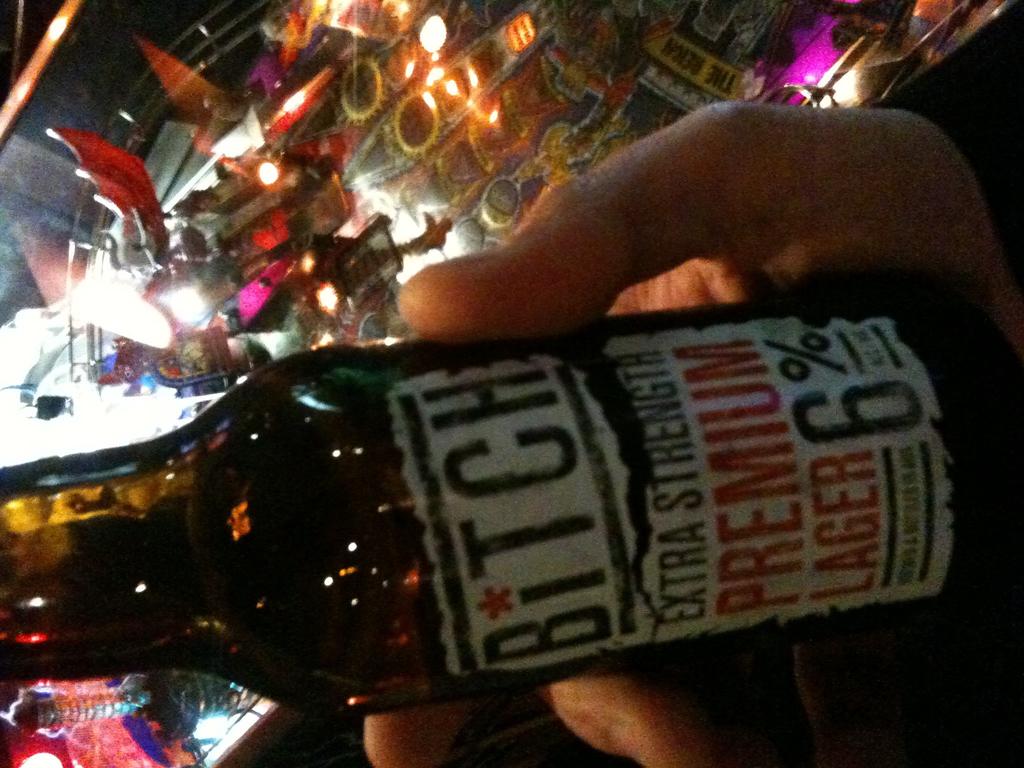What percent alcohol does the beer contain?
Make the answer very short. 6%. What strength is this beer?
Provide a succinct answer. 6%. 